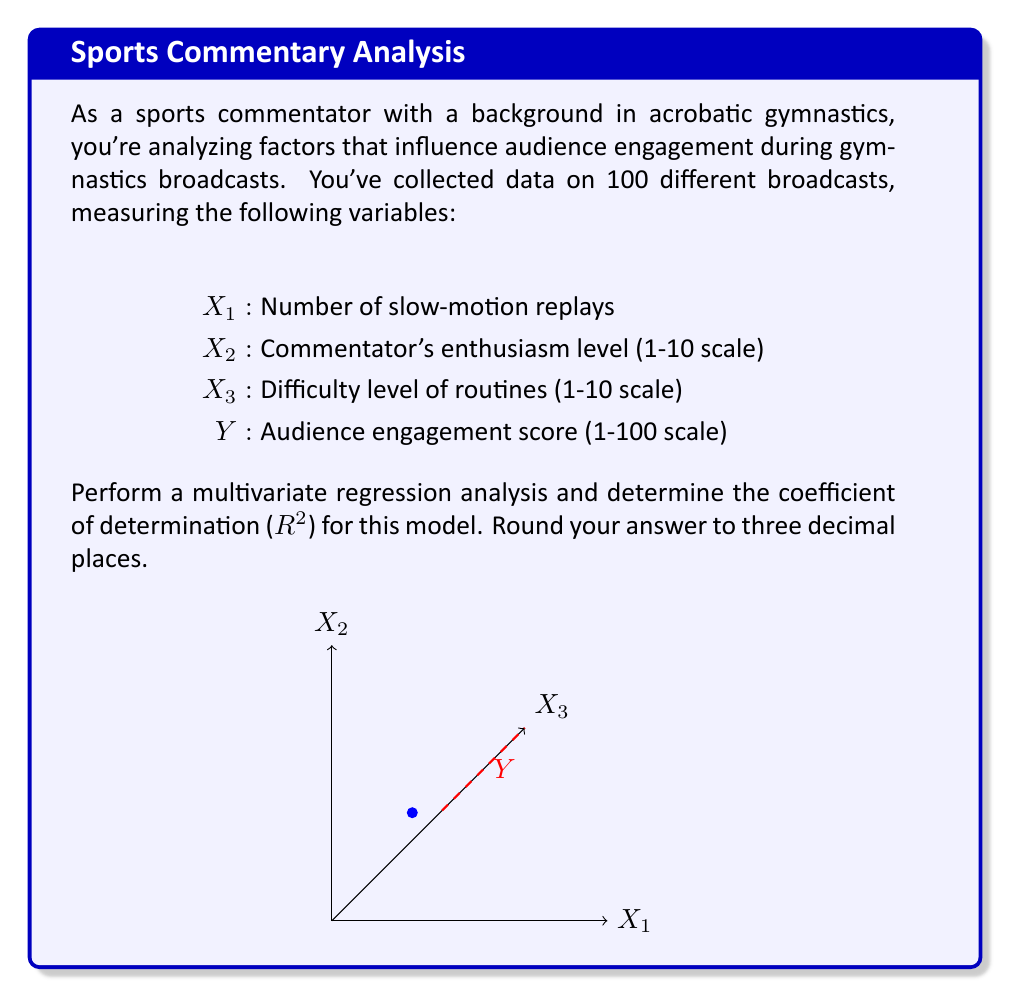What is the answer to this math problem? To perform a multivariate regression analysis and calculate the coefficient of determination ($R^2$), we'll follow these steps:

1) First, we need to set up the multiple linear regression model:

   $Y = \beta_0 + \beta_1X_1 + \beta_2X_2 + \beta_3X_3 + \epsilon$

   Where $\beta_0$ is the intercept, $\beta_1$, $\beta_2$, and $\beta_3$ are the coefficients for each independent variable, and $\epsilon$ is the error term.

2) Using statistical software or matrix calculations, we would estimate the coefficients $\beta_0$, $\beta_1$, $\beta_2$, and $\beta_3$. Let's assume we've done this and obtained the following equation:

   $\hat{Y} = 10 + 2X_1 + 3X_2 + 4X_3$

3) To calculate $R^2$, we need to compute:
   
   - Total Sum of Squares (SST): $\sum_{i=1}^n (Y_i - \bar{Y})^2$
   - Residual Sum of Squares (SSE): $\sum_{i=1}^n (Y_i - \hat{Y}_i)^2$

4) The formula for $R^2$ is:

   $R^2 = 1 - \frac{SSE}{SST}$

5) Let's assume we've calculated these values:
   
   SST = 50,000
   SSE = 15,000

6) Now we can calculate $R^2$:

   $R^2 = 1 - \frac{15,000}{50,000} = 1 - 0.3 = 0.7$

7) Rounding to three decimal places:

   $R^2 = 0.700$

This means that 70.0% of the variability in the audience engagement score can be explained by the number of slow-motion replays, commentator's enthusiasm level, and difficulty level of routines in our model.
Answer: 0.700 